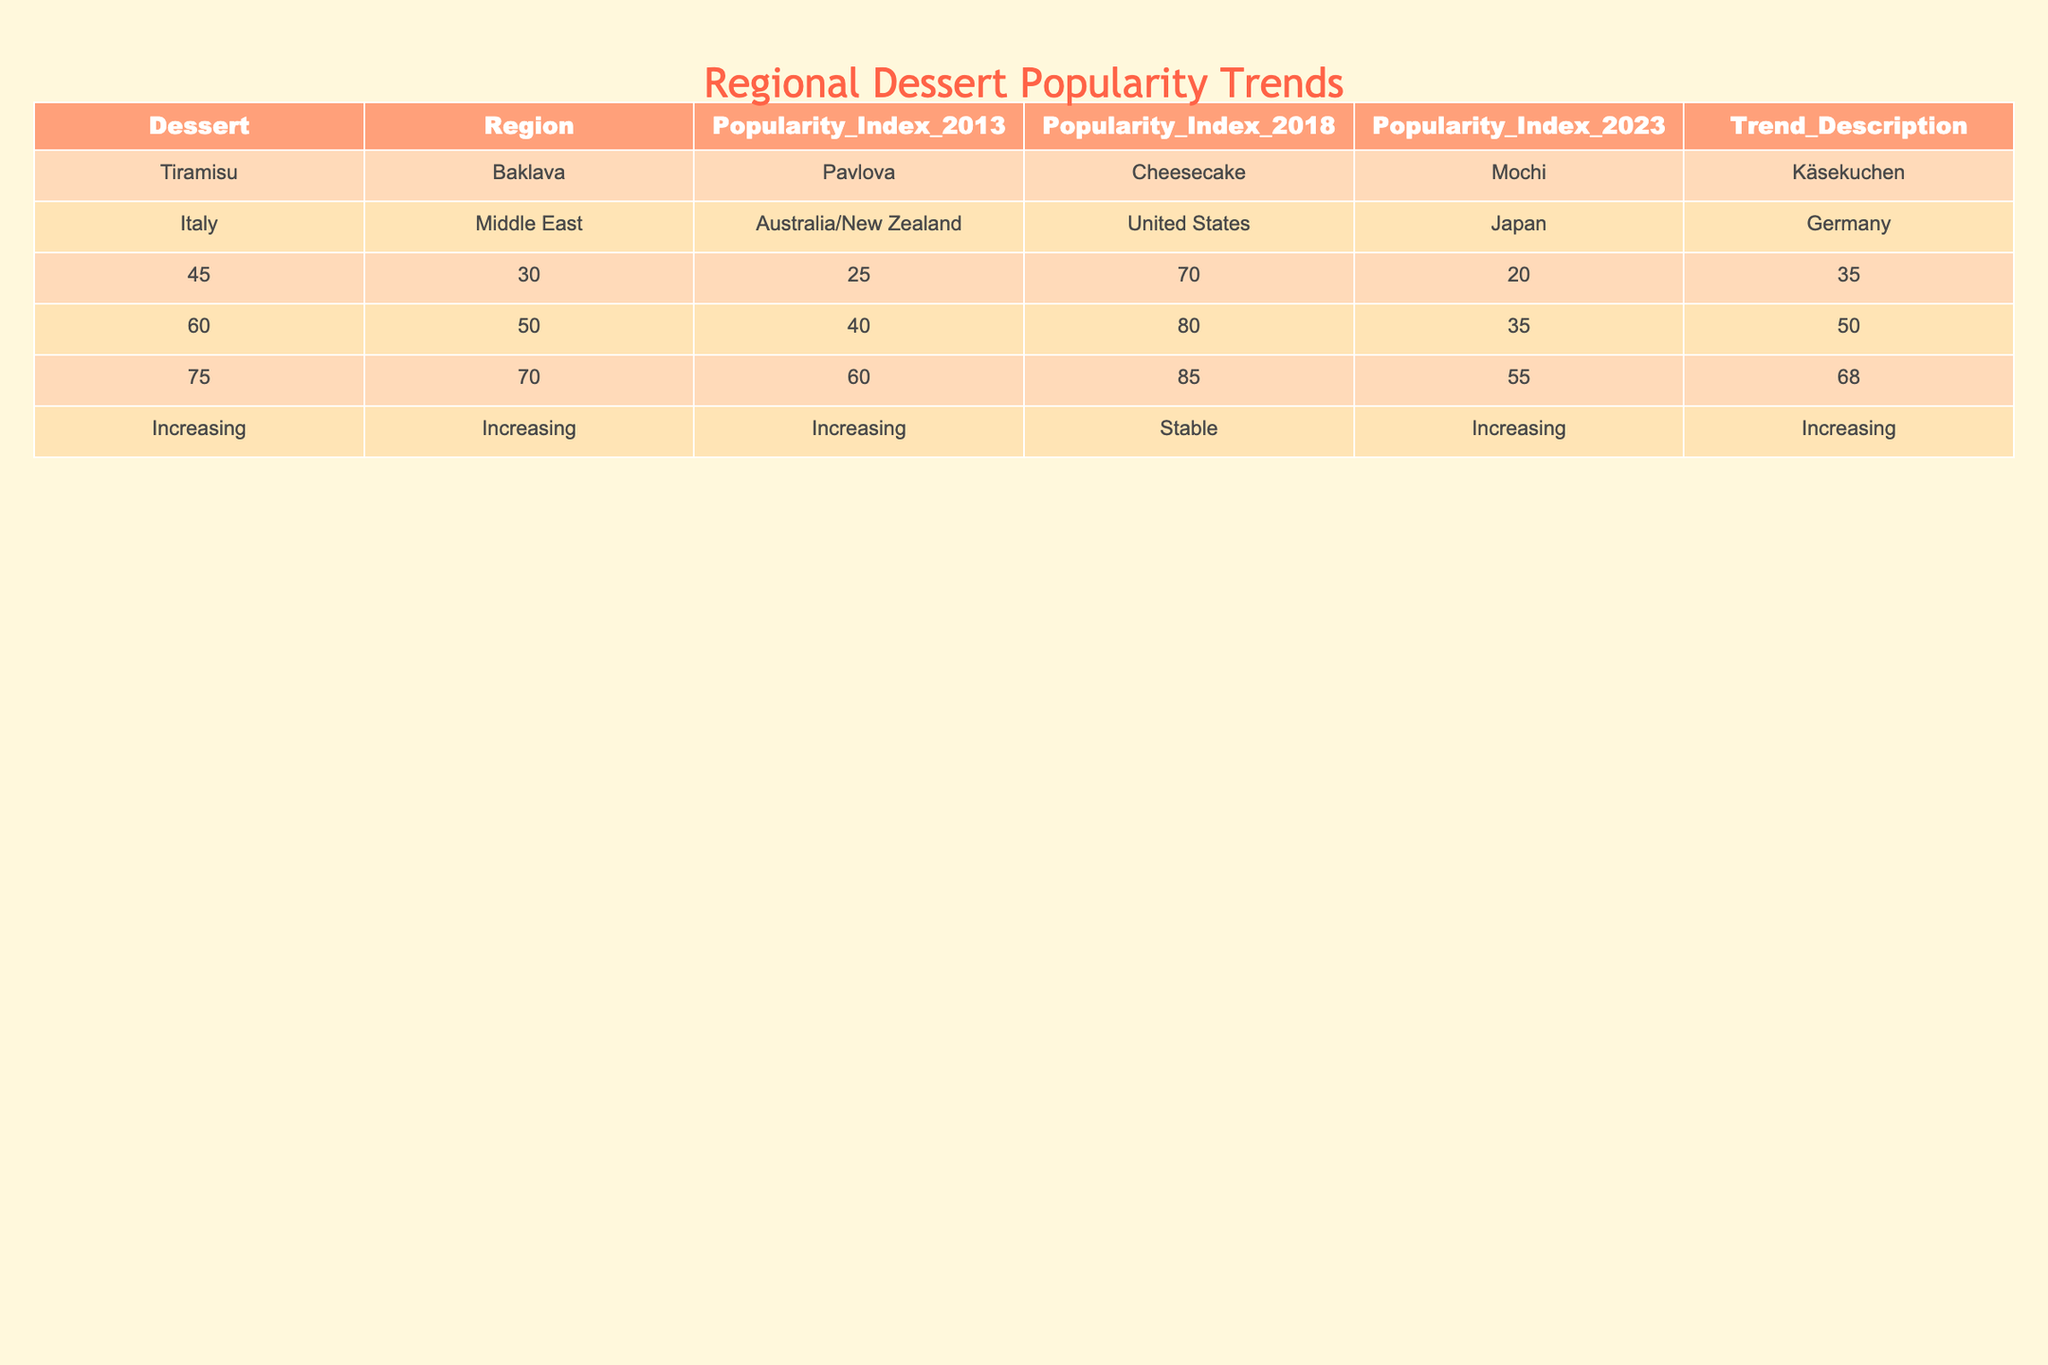What dessert had the highest popularity index in 2023? By checking the Popularity Index for each dessert in 2023, I see that Macarons have a value of 90, which is the highest among all listed desserts.
Answer: Macarons Which region's dessert showed a stable trend over the past decade? Looking at the Trend Description column, the desserts under the United States (Cheesecake and S'mores), India (Gulab Jamun), Austria (Sacher Torte), and Germany (Stollen) are marked as stable, meaning their popularity did not show significant changes.
Answer: United States, India, Austria, Germany What is the average popularity index of desserts from Latin America in 2023? The desserts from Latin America listed in the table are Flan and Tres Leches Cake with popularity indices of 80 and 45 respectively. To find the average, I calculate (80 + 45) / 2 = 62.5.
Answer: 62.5 What is the difference in popularity index for Tiramisu between 2013 and 2023? The Popularity Index for Tiramisu in 2013 is 45 and in 2023 is 75. Subtracting the two values gives 75 - 45 = 30, indicating an increase of 30 over the decade.
Answer: 30 Which dessert enjoyed the greatest increase in popularity from 2013 to 2023? To determine this, I will calculate the increase for each dessert by subtracting the 2013 value from the 2023 value. The maximum increase is seen in Baklava, with an increase of 40 (70 - 30) from 2013 to 2023.
Answer: Baklava Is there any dessert in the table that has a decreasing trend? By reviewing the Trend Description column, all listed desserts have increasing or stable trends. Therefore, there are no desserts with a decreasing trend.
Answer: No What percentage of desserts listed had a popularity rating above 60 in 2023? In 2023, the desserts with a popularity rating above 60 are Tiramisu, Baklava, Cheesecake, Macarons, Flan, Choux Cream, and S'mores, totaling 7 desserts out of 20. The percentage is (7/20) * 100 = 35%.
Answer: 35% Which two regions have desserts that exhibit the same popularity index in 2023? Looking through the Popularity Index for 2023, both Gulab Jamun (India) and Pavlova (Australia/New Zealand) have a popularity index of 70. Hence, they share the same ranking in 2023.
Answer: India and Australia/New Zealand What trend does the dessert with the lowest popularity index in 2023 show? The dessert with the lowest popularity index in 2023 is Kruidnoten, which has a value of 30 and is described as increasing, indicating a positive trend despite its low index.
Answer: Increasing How much did the popularity index of Cheesecake increase from 2013 to 2023? For Cheesecake, the index in 2013 was 70 and in 2023 it is 85. The change is 85 - 70 = 15, showing a modest increase in popularity.
Answer: 15 